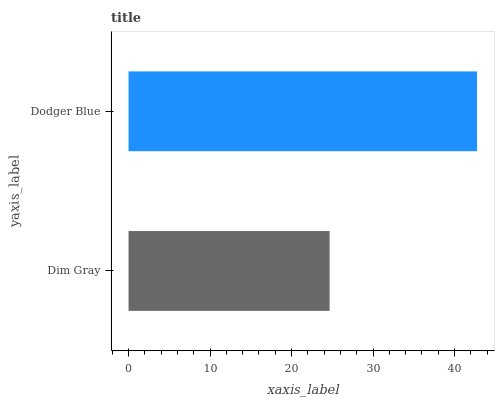Is Dim Gray the minimum?
Answer yes or no. Yes. Is Dodger Blue the maximum?
Answer yes or no. Yes. Is Dodger Blue the minimum?
Answer yes or no. No. Is Dodger Blue greater than Dim Gray?
Answer yes or no. Yes. Is Dim Gray less than Dodger Blue?
Answer yes or no. Yes. Is Dim Gray greater than Dodger Blue?
Answer yes or no. No. Is Dodger Blue less than Dim Gray?
Answer yes or no. No. Is Dodger Blue the high median?
Answer yes or no. Yes. Is Dim Gray the low median?
Answer yes or no. Yes. Is Dim Gray the high median?
Answer yes or no. No. Is Dodger Blue the low median?
Answer yes or no. No. 